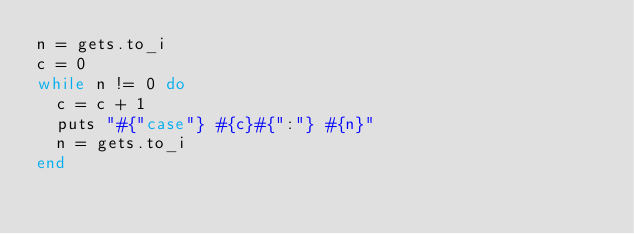Convert code to text. <code><loc_0><loc_0><loc_500><loc_500><_Ruby_>n = gets.to_i
c = 0
while n != 0 do
	c = c + 1
	puts "#{"case"} #{c}#{":"} #{n}"
	n = gets.to_i
end</code> 